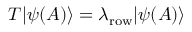Convert formula to latex. <formula><loc_0><loc_0><loc_500><loc_500>T | \psi ( A ) \rangle = \lambda _ { r o w } | \psi ( A ) \rangle</formula> 